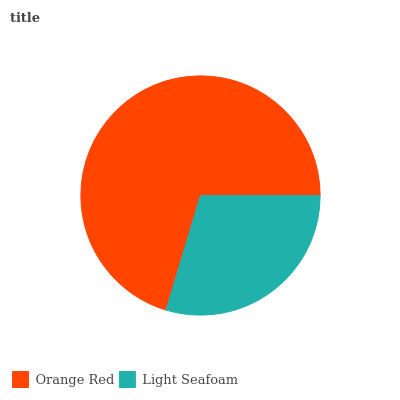Is Light Seafoam the minimum?
Answer yes or no. Yes. Is Orange Red the maximum?
Answer yes or no. Yes. Is Light Seafoam the maximum?
Answer yes or no. No. Is Orange Red greater than Light Seafoam?
Answer yes or no. Yes. Is Light Seafoam less than Orange Red?
Answer yes or no. Yes. Is Light Seafoam greater than Orange Red?
Answer yes or no. No. Is Orange Red less than Light Seafoam?
Answer yes or no. No. Is Orange Red the high median?
Answer yes or no. Yes. Is Light Seafoam the low median?
Answer yes or no. Yes. Is Light Seafoam the high median?
Answer yes or no. No. Is Orange Red the low median?
Answer yes or no. No. 